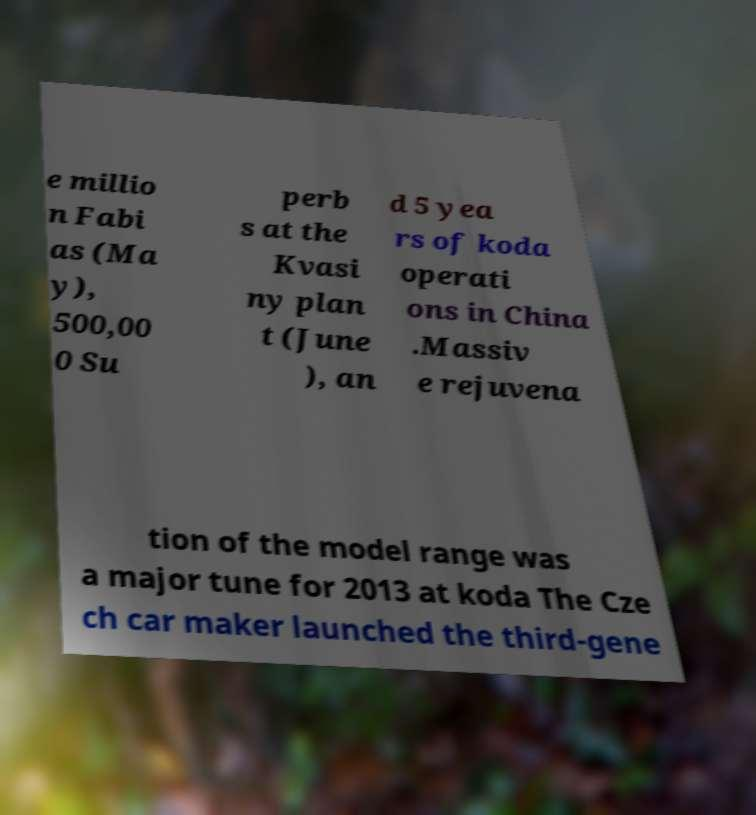Could you extract and type out the text from this image? e millio n Fabi as (Ma y), 500,00 0 Su perb s at the Kvasi ny plan t (June ), an d 5 yea rs of koda operati ons in China .Massiv e rejuvena tion of the model range was a major tune for 2013 at koda The Cze ch car maker launched the third-gene 